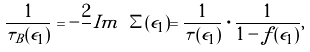Convert formula to latex. <formula><loc_0><loc_0><loc_500><loc_500>\frac { 1 } { \tau _ { B } ( \epsilon _ { 1 } ) } = - \frac { 2 } { } I m \ \Sigma ( \epsilon _ { 1 } ) = \frac { 1 } { \tau ( \epsilon _ { 1 } ) } \cdot \frac { 1 } { 1 - f ( \epsilon _ { 1 } ) } ,</formula> 